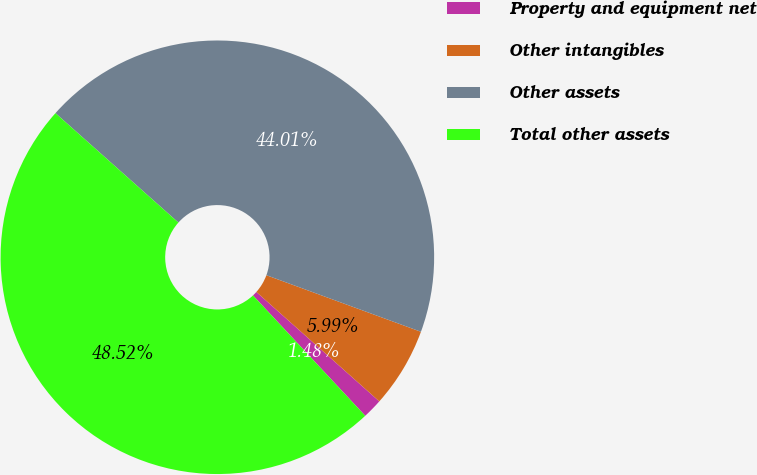Convert chart. <chart><loc_0><loc_0><loc_500><loc_500><pie_chart><fcel>Property and equipment net<fcel>Other intangibles<fcel>Other assets<fcel>Total other assets<nl><fcel>1.48%<fcel>5.99%<fcel>44.01%<fcel>48.52%<nl></chart> 